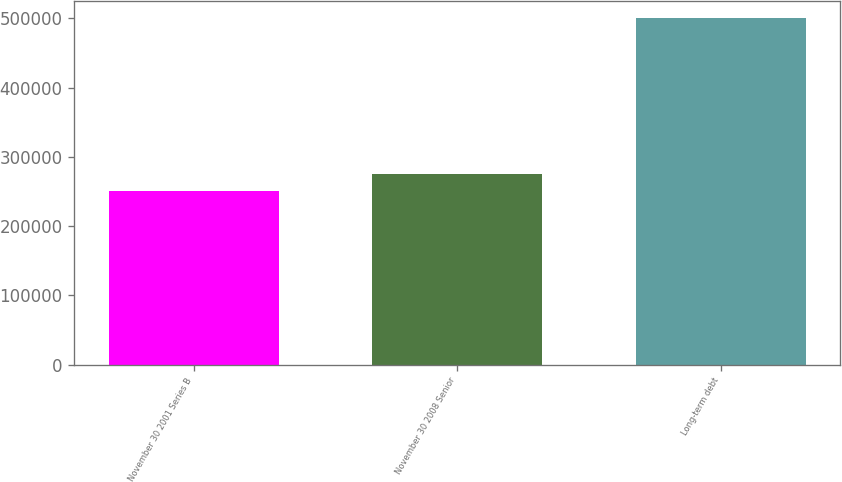Convert chart. <chart><loc_0><loc_0><loc_500><loc_500><bar_chart><fcel>November 30 2001 Series B<fcel>November 30 2008 Senior<fcel>Long-term debt<nl><fcel>250000<fcel>275000<fcel>500000<nl></chart> 